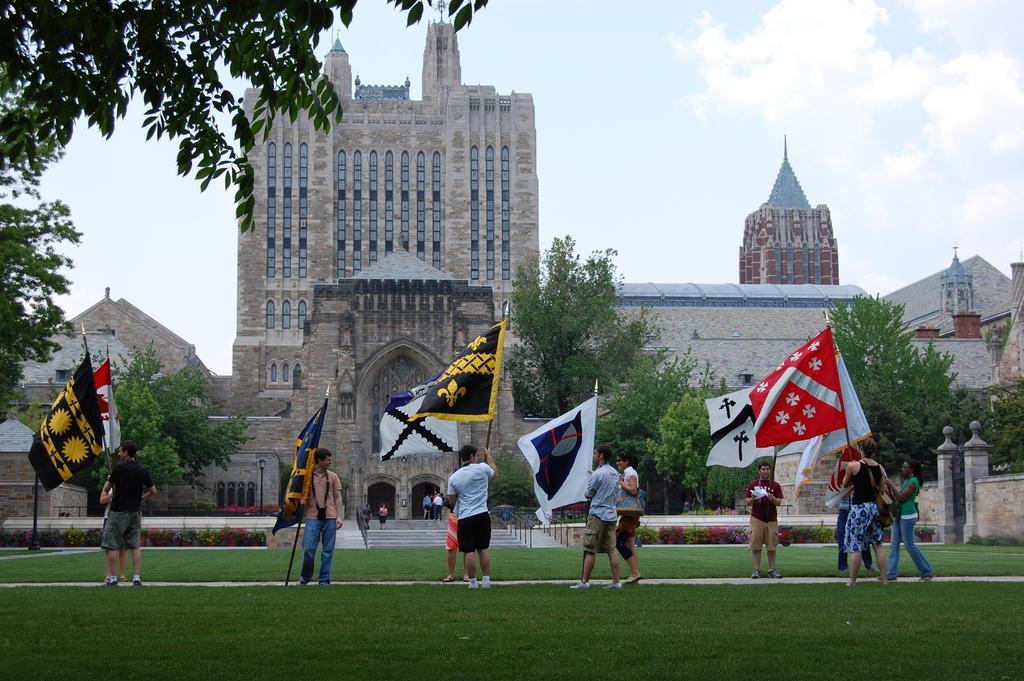Could you give a brief overview of what you see in this image? In this image we can see there are few people holding a flag in their hand and standing on the surface of the grass. In the background there is a building, in front of the building there are some trees. 